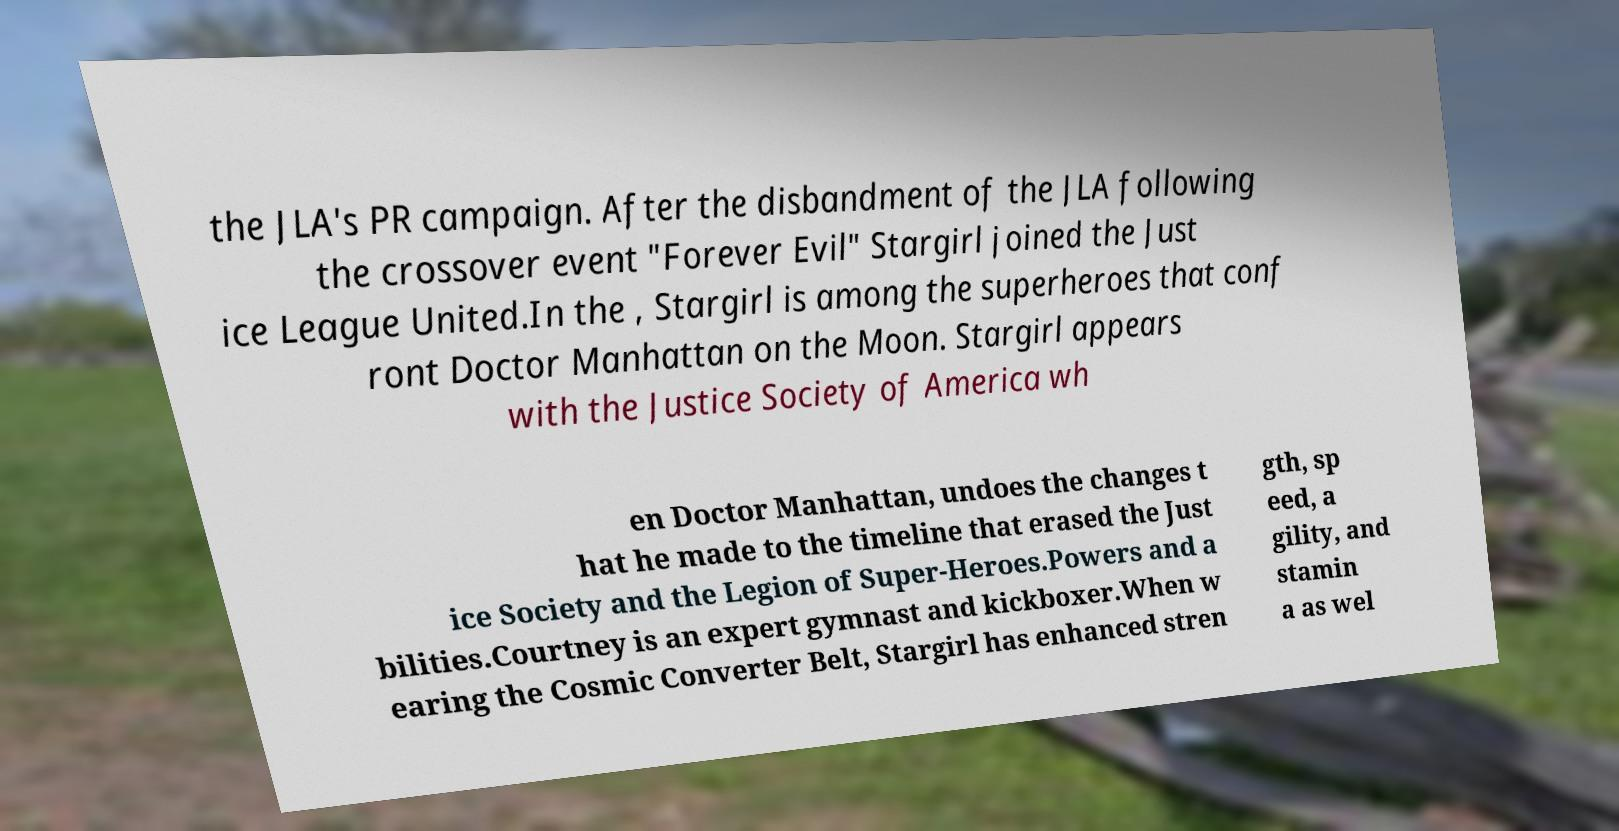Please identify and transcribe the text found in this image. the JLA's PR campaign. After the disbandment of the JLA following the crossover event "Forever Evil" Stargirl joined the Just ice League United.In the , Stargirl is among the superheroes that conf ront Doctor Manhattan on the Moon. Stargirl appears with the Justice Society of America wh en Doctor Manhattan, undoes the changes t hat he made to the timeline that erased the Just ice Society and the Legion of Super-Heroes.Powers and a bilities.Courtney is an expert gymnast and kickboxer.When w earing the Cosmic Converter Belt, Stargirl has enhanced stren gth, sp eed, a gility, and stamin a as wel 